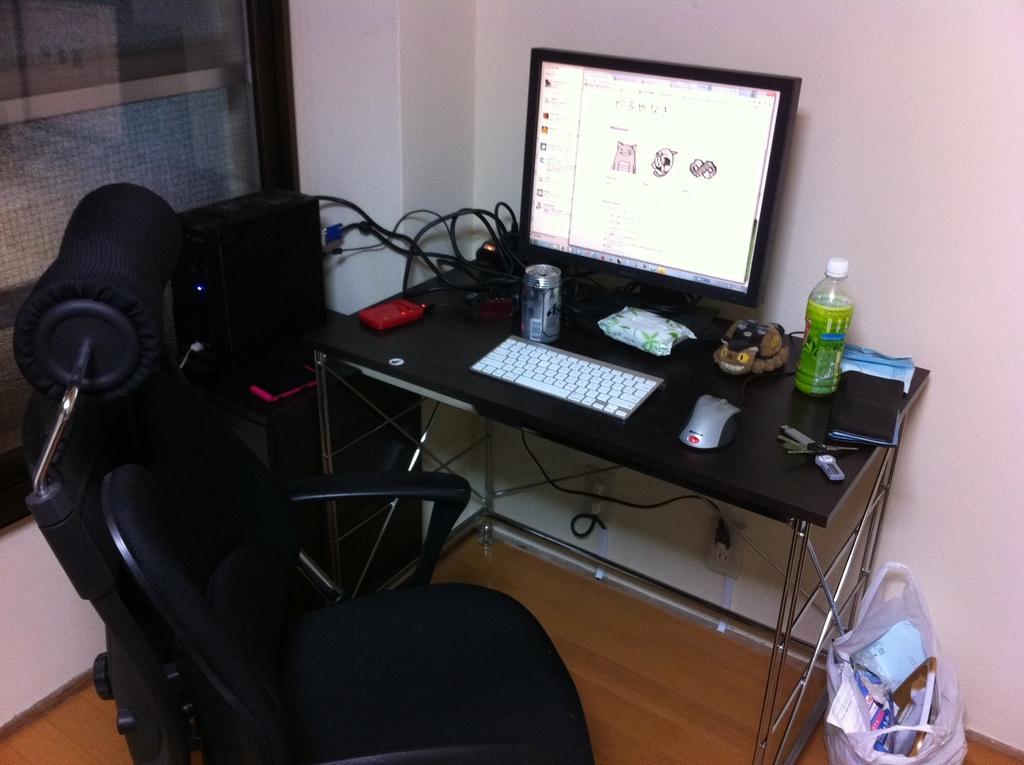Could you give a brief overview of what you see in this image? In this image I see a monitor, keyboard, mouse, can, a bottle and wires on the table. I can also see there is a chair, a cover and the wall. 